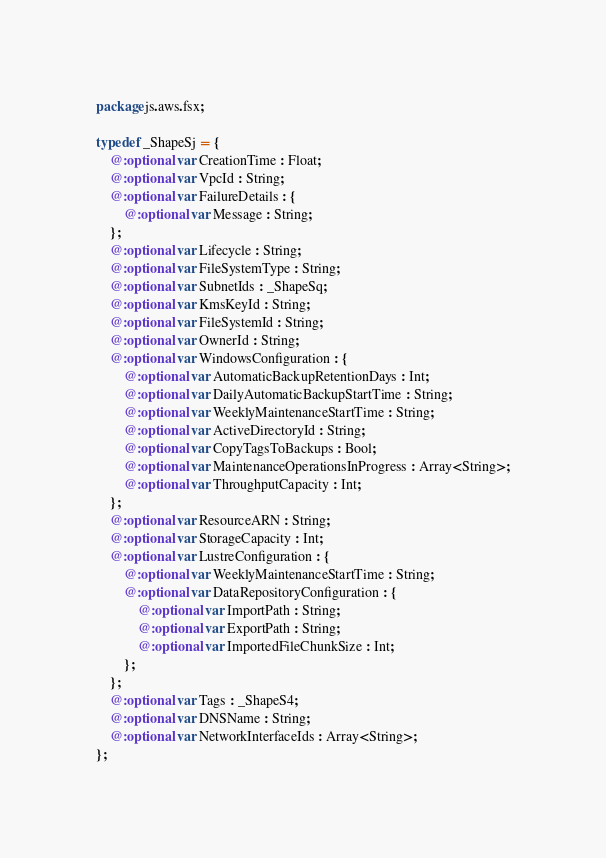Convert code to text. <code><loc_0><loc_0><loc_500><loc_500><_Haxe_>package js.aws.fsx;

typedef _ShapeSj = {
    @:optional var CreationTime : Float;
    @:optional var VpcId : String;
    @:optional var FailureDetails : {
        @:optional var Message : String;
    };
    @:optional var Lifecycle : String;
    @:optional var FileSystemType : String;
    @:optional var SubnetIds : _ShapeSq;
    @:optional var KmsKeyId : String;
    @:optional var FileSystemId : String;
    @:optional var OwnerId : String;
    @:optional var WindowsConfiguration : {
        @:optional var AutomaticBackupRetentionDays : Int;
        @:optional var DailyAutomaticBackupStartTime : String;
        @:optional var WeeklyMaintenanceStartTime : String;
        @:optional var ActiveDirectoryId : String;
        @:optional var CopyTagsToBackups : Bool;
        @:optional var MaintenanceOperationsInProgress : Array<String>;
        @:optional var ThroughputCapacity : Int;
    };
    @:optional var ResourceARN : String;
    @:optional var StorageCapacity : Int;
    @:optional var LustreConfiguration : {
        @:optional var WeeklyMaintenanceStartTime : String;
        @:optional var DataRepositoryConfiguration : {
            @:optional var ImportPath : String;
            @:optional var ExportPath : String;
            @:optional var ImportedFileChunkSize : Int;
        };
    };
    @:optional var Tags : _ShapeS4;
    @:optional var DNSName : String;
    @:optional var NetworkInterfaceIds : Array<String>;
};
</code> 